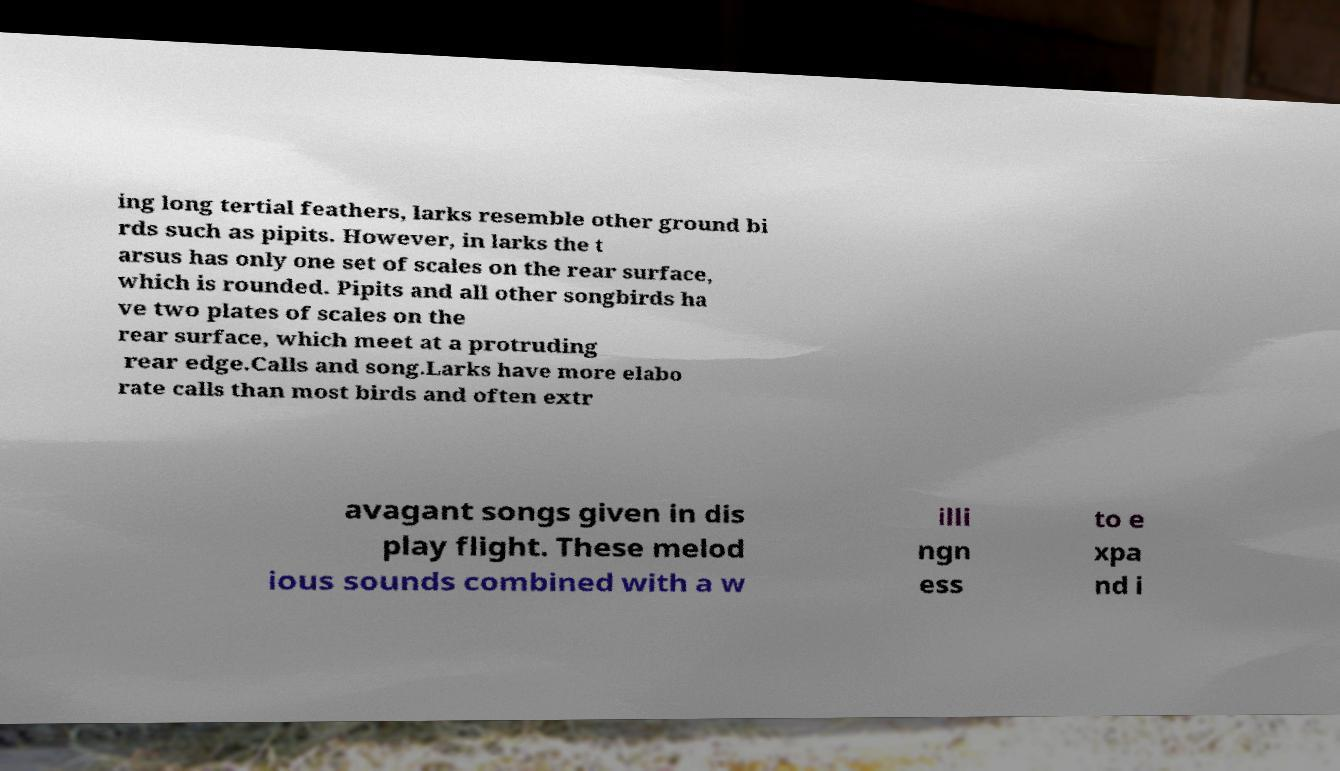Can you read and provide the text displayed in the image?This photo seems to have some interesting text. Can you extract and type it out for me? ing long tertial feathers, larks resemble other ground bi rds such as pipits. However, in larks the t arsus has only one set of scales on the rear surface, which is rounded. Pipits and all other songbirds ha ve two plates of scales on the rear surface, which meet at a protruding rear edge.Calls and song.Larks have more elabo rate calls than most birds and often extr avagant songs given in dis play flight. These melod ious sounds combined with a w illi ngn ess to e xpa nd i 